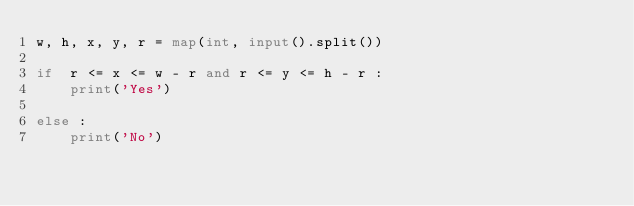<code> <loc_0><loc_0><loc_500><loc_500><_Python_>w, h, x, y, r = map(int, input().split())

if  r <= x <= w - r and r <= y <= h - r :
    print('Yes')

else :
    print('No')
</code> 